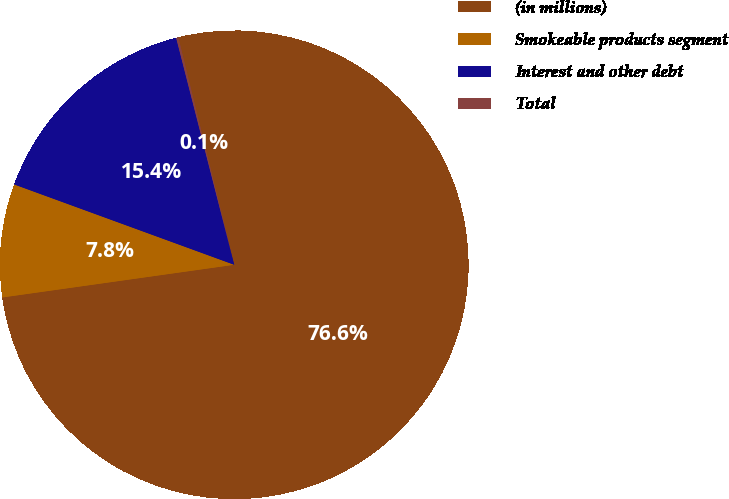<chart> <loc_0><loc_0><loc_500><loc_500><pie_chart><fcel>(in millions)<fcel>Smokeable products segment<fcel>Interest and other debt<fcel>Total<nl><fcel>76.61%<fcel>7.8%<fcel>15.44%<fcel>0.15%<nl></chart> 